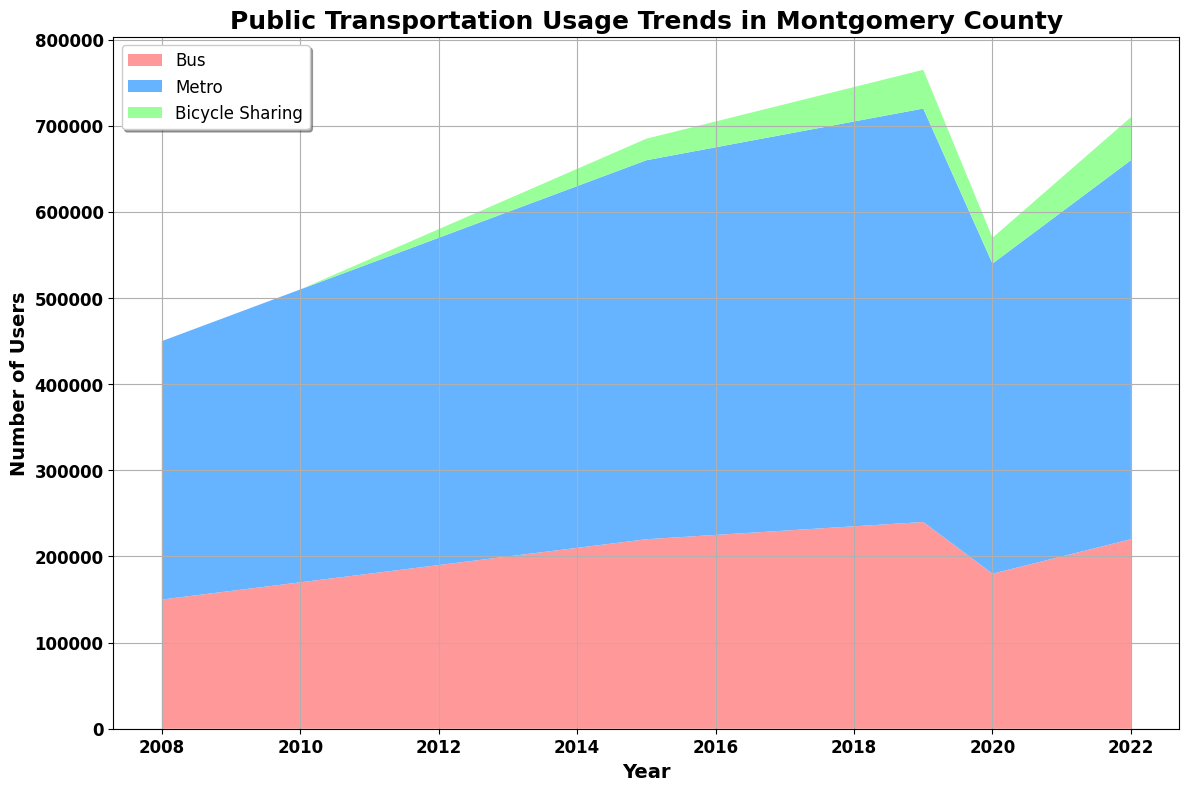What's the trend of bus usage from 2008 to 2022? Observing the 'Bus' section of the area chart, it shows a steady increase in bus usage from 2008 to 2019, a dip in 2020, followed by a recovery in 2021, and a further increase in 2022.
Answer: Steady increase with a dip in 2020 Which mode of transport has the highest number of users in 2022? By examining the heights of the sections for the year 2022, the 'Metro' section is the tallest, indicating the highest number of users among the transport modes.
Answer: Metro How does the increase in bicycle-sharing usage compare to bus and metro from 2011 to 2019? Between 2011 and 2019, the bicycle-sharing segment shows a rapid increase from 5,000 to 45,000 users. Bus and metro usage also increased, but at a slower and more steady rate.
Answer: Faster increase for bicycle-sharing What happened to the public transport usage in 2020? The combined height of all sections decreases in 2020, indicating there was a drop across all types of public transport that year.
Answer: Decrease Calculate the total number of bus users from 2008 to 2012. Sum the values for bus users for each year from 2008 to 2012: 150,000 + 160,000 + 170,000 + 180,000 + 190,000 = 850,000.
Answer: 850,000 Which year introduced bicycle-sharing, and how significant was its initial usage? Bicycle-sharing first appears in the area chart in 2011 with 5,000 users, as indicated by the green section starting in that year.
Answer: 2011, 5,000 users When did metro usage reach 450,000 users, and what was the trend before and after this point? Metro usage reached 450,000 users in 2016. The trend shows a steady increase before and after this point.
Answer: 2016, steady increase In which year was the gap between bus and metro usage the smallest, and what were the usage numbers? The smallest gap appears in 2020, with bus at 180,000 and metro at 360,000 users, thus a difference of 180,000 users.
Answer: 2020, bus: 180,000, metro: 360,000 By how much did bicycle-sharing users change between 2020 and 2022? The number of bicycle-sharing users increased from 30,000 in 2020 to 50,000 in 2022, making a total change of 20,000 users.
Answer: Increased by 20,000 